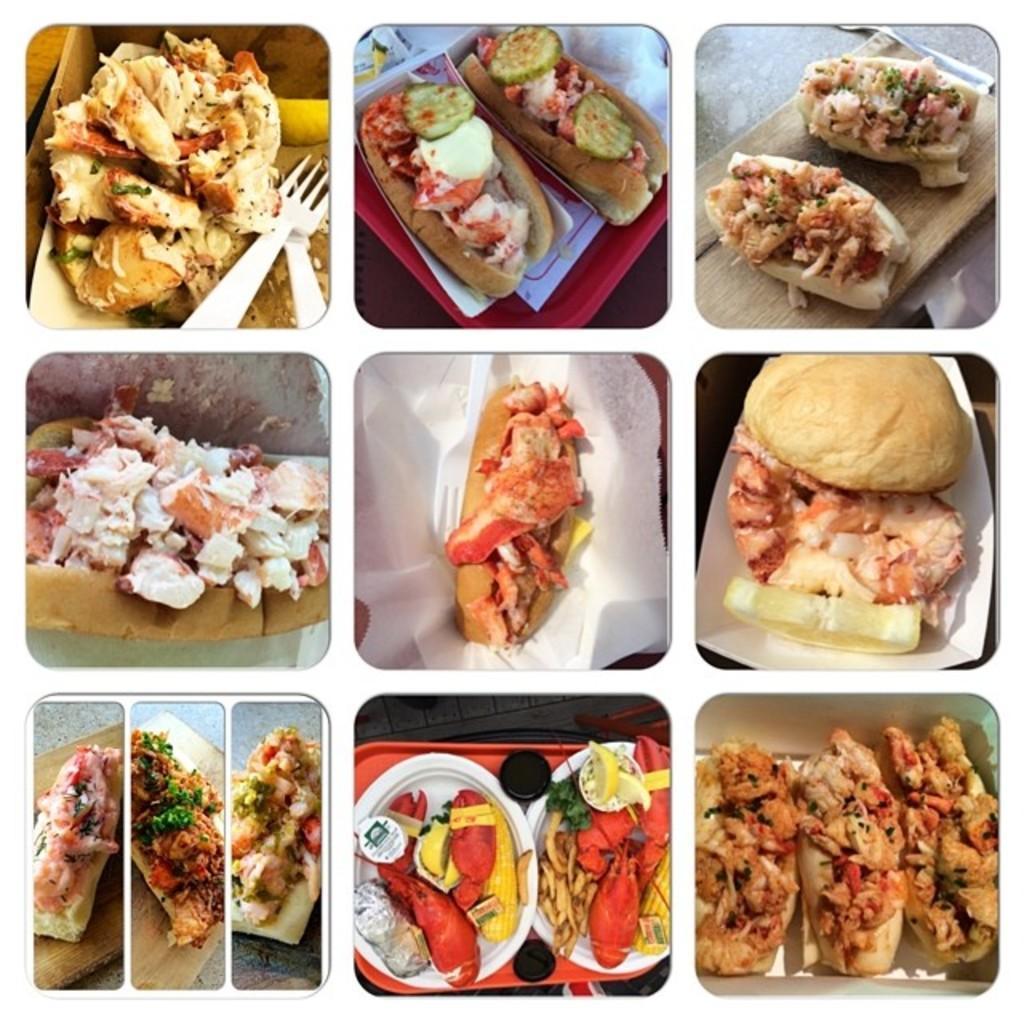Could you give a brief overview of what you see in this image? In this image we can see a collage of pictures, in which we can see food placed on the surface. 